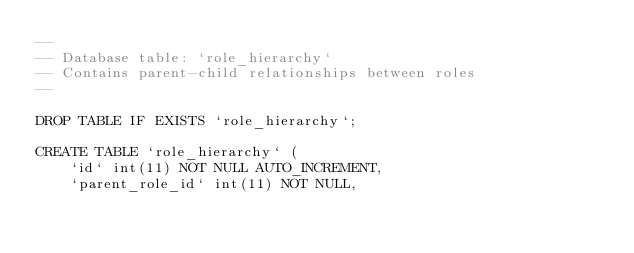<code> <loc_0><loc_0><loc_500><loc_500><_SQL_>--
-- Database table: `role_hierarchy`
-- Contains parent-child relationships between roles
--

DROP TABLE IF EXISTS `role_hierarchy`;

CREATE TABLE `role_hierarchy` (
    `id` int(11) NOT NULL AUTO_INCREMENT,
    `parent_role_id` int(11) NOT NULL,</code> 